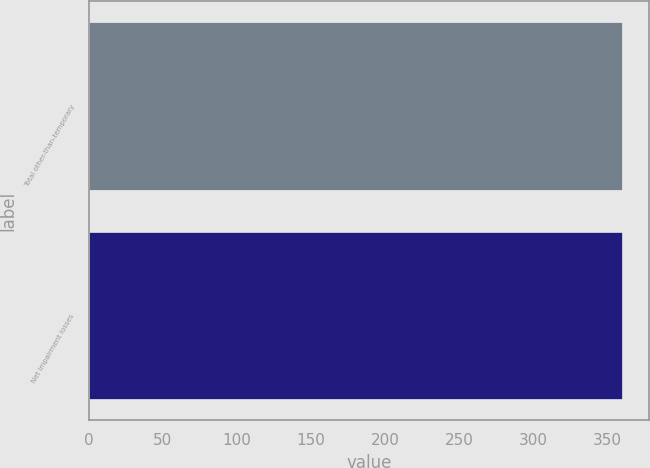Convert chart. <chart><loc_0><loc_0><loc_500><loc_500><bar_chart><fcel>Total other-than-temporary<fcel>Net impairment losses<nl><fcel>360<fcel>360.1<nl></chart> 